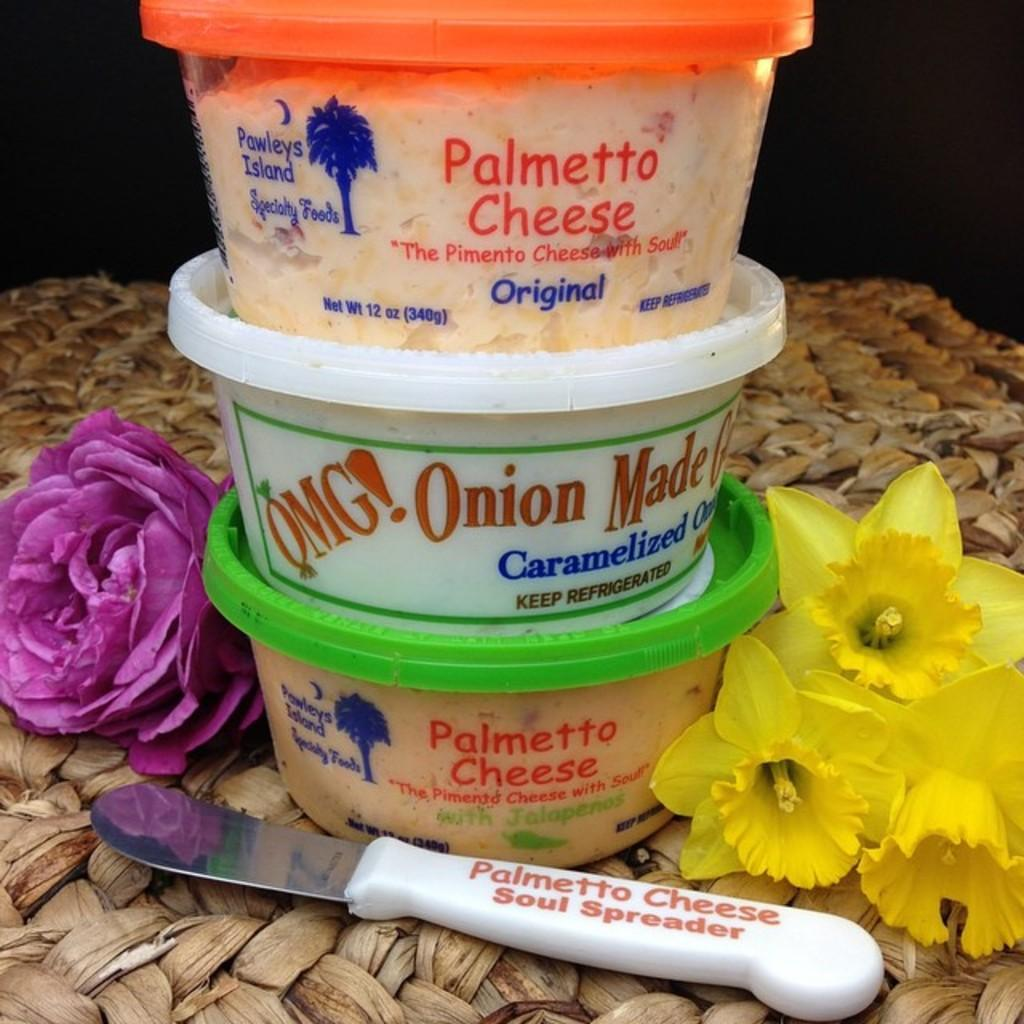<image>
Relay a brief, clear account of the picture shown. three containers of Palmetto Cheese, OMG! Carmelized Onions, and a Palmetto Cheese Soul Spreader. 